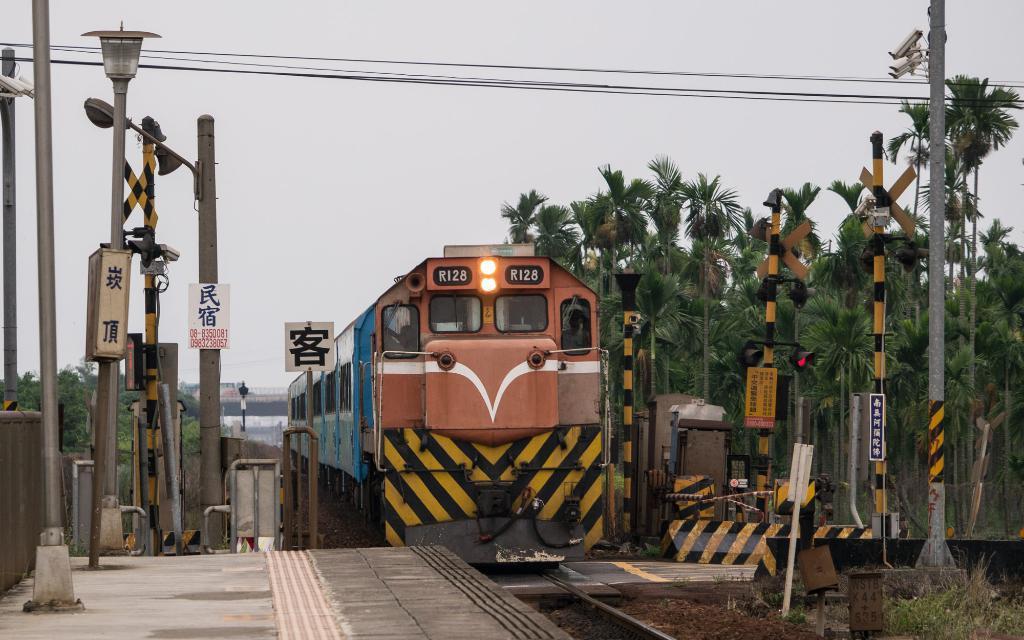Please provide a concise description of this image. In this picture, we see a train in brown and blue color is moving on the tracks. On either side of the tracks, we see street lights and poles. There are trees on the right side of the picture. At the top of the picture, we see the wires and the sky. There are trees and a bridge in the background. 